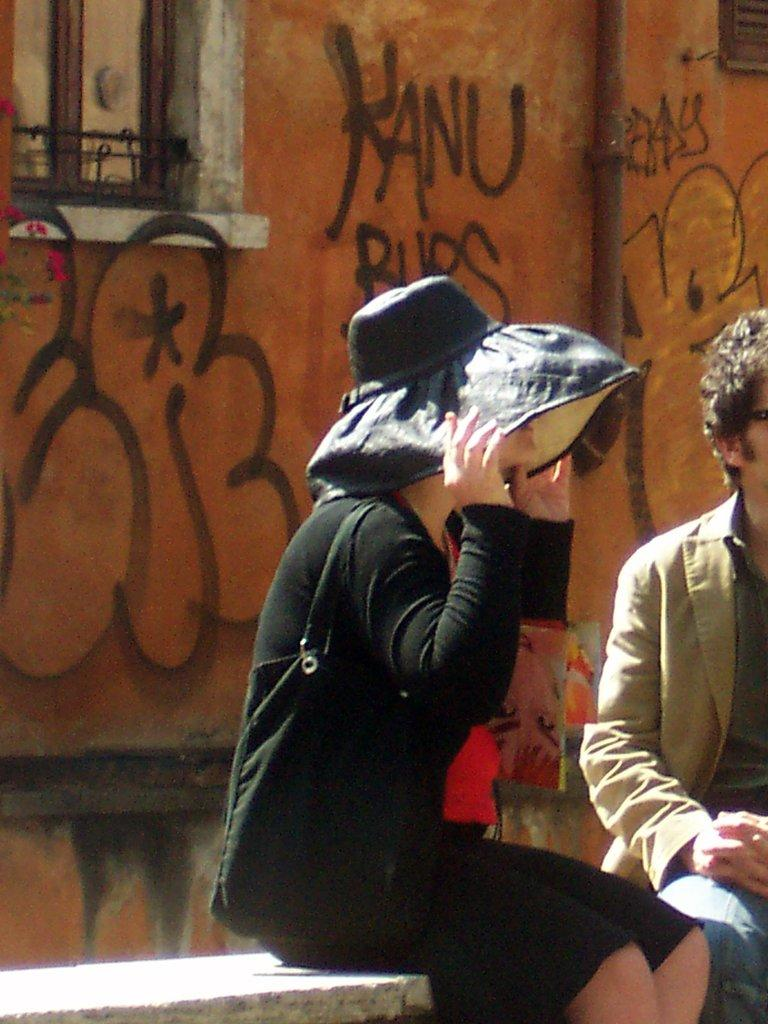<image>
Relay a brief, clear account of the picture shown. Woman sitting next to a brown wall that says "KANU" on it. 